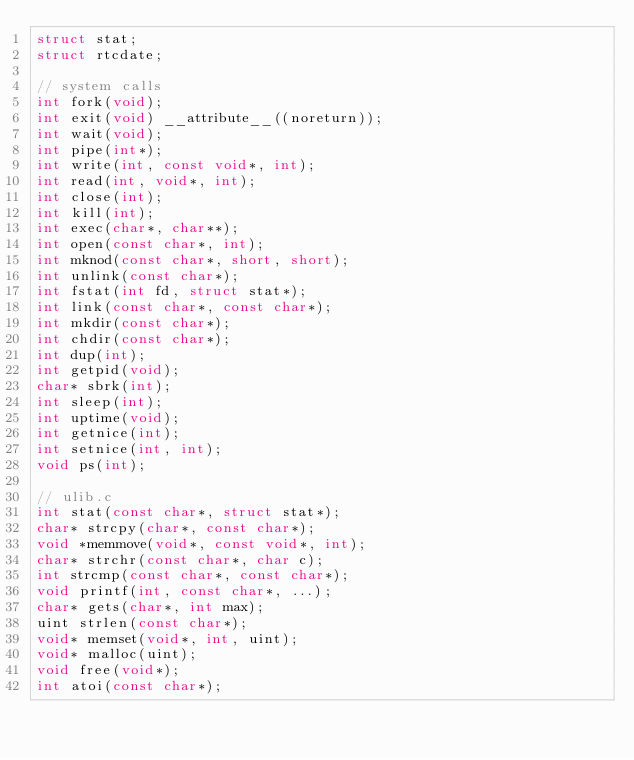Convert code to text. <code><loc_0><loc_0><loc_500><loc_500><_C_>struct stat;
struct rtcdate;

// system calls
int fork(void);
int exit(void) __attribute__((noreturn));
int wait(void);
int pipe(int*);
int write(int, const void*, int);
int read(int, void*, int);
int close(int);
int kill(int);
int exec(char*, char**);
int open(const char*, int);
int mknod(const char*, short, short);
int unlink(const char*);
int fstat(int fd, struct stat*);
int link(const char*, const char*);
int mkdir(const char*);
int chdir(const char*);
int dup(int);
int getpid(void);
char* sbrk(int);
int sleep(int);
int uptime(void);
int getnice(int);
int setnice(int, int);
void ps(int);

// ulib.c
int stat(const char*, struct stat*);
char* strcpy(char*, const char*);
void *memmove(void*, const void*, int);
char* strchr(const char*, char c);
int strcmp(const char*, const char*);
void printf(int, const char*, ...);
char* gets(char*, int max);
uint strlen(const char*);
void* memset(void*, int, uint);
void* malloc(uint);
void free(void*);
int atoi(const char*);
</code> 